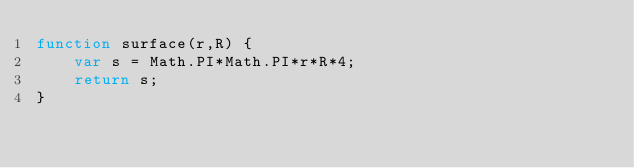Convert code to text. <code><loc_0><loc_0><loc_500><loc_500><_JavaScript_>function surface(r,R) {
	var s = Math.PI*Math.PI*r*R*4;
	return s;
}</code> 